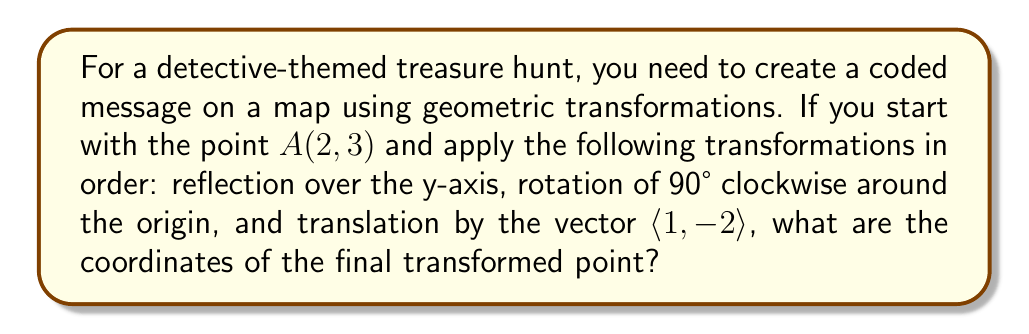Help me with this question. Let's approach this step-by-step:

1. Reflection over the y-axis:
   The reflection of point $A(2, 3)$ over the y-axis changes the x-coordinate to its opposite.
   $A_1(-2, 3)$

2. Rotation of 90° clockwise around the origin:
   For a 90° clockwise rotation, we use the formula:
   $x' = y$
   $y' = -x$
   So, $A_2(3, 2)$

3. Translation by the vector $\langle 1, -2 \rangle$:
   Add the vector components to the current coordinates.
   $x' = x + 1$
   $y' = y + (-2)$
   Final point: $A_3(3+1, 2-2) = (4, 0)$

Therefore, the final transformed point has coordinates $(4, 0)$.
Answer: $(4, 0)$ 